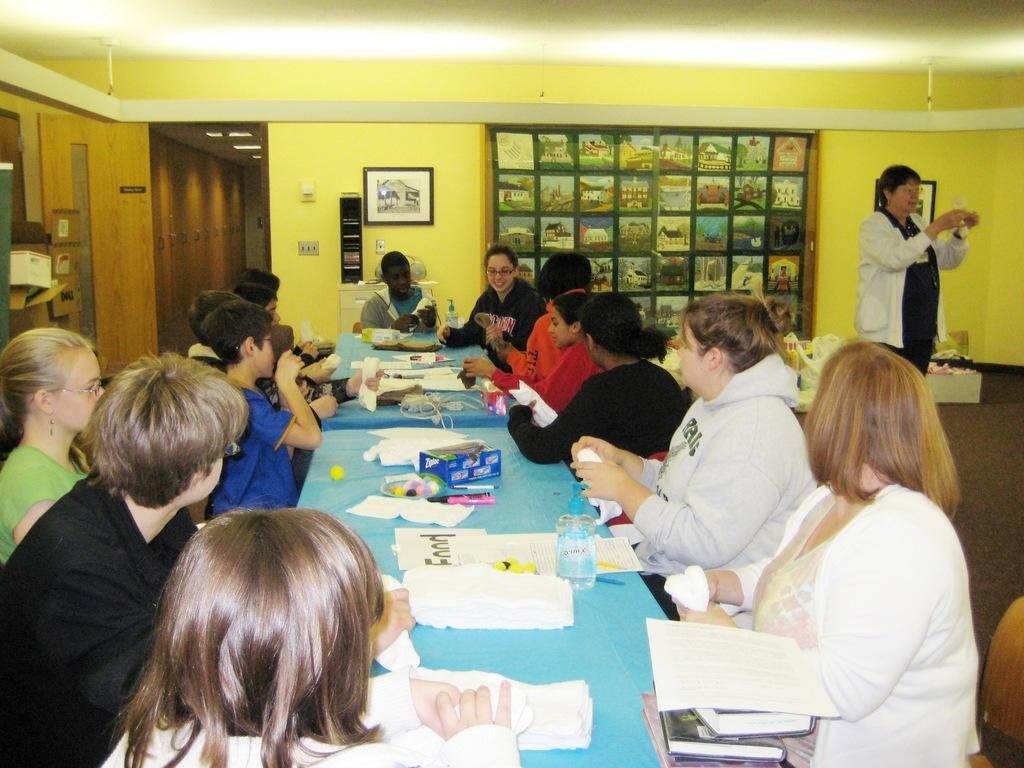What are the people in the image doing? The people in the image are sitting on chairs. What is on the table in the image? There is a table in the image with papers, a water bottle, a pen, and a marker on it. What can be seen on the wall in the image? There are photo frames on the wall. What is the daughter's favorite color in the image? There is no mention of a daughter in the image, so we cannot determine her favorite color. 